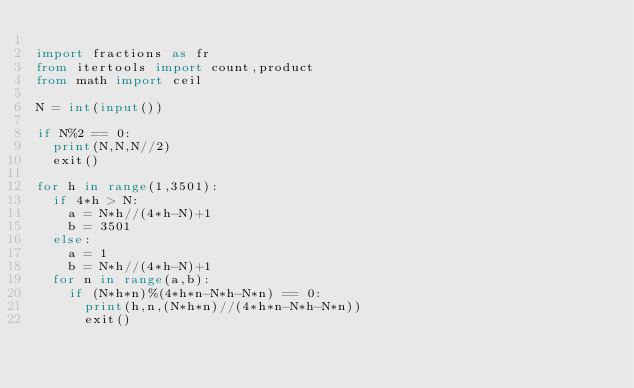<code> <loc_0><loc_0><loc_500><loc_500><_Python_>
import fractions as fr
from itertools import count,product
from math import ceil

N = int(input())

if N%2 == 0:
  print(N,N,N//2)
  exit()

for h in range(1,3501):
  if 4*h > N:
    a = N*h//(4*h-N)+1
    b = 3501
  else:
    a = 1
    b = N*h//(4*h-N)+1
  for n in range(a,b):
    if (N*h*n)%(4*h*n-N*h-N*n) == 0:
      print(h,n,(N*h*n)//(4*h*n-N*h-N*n))
      exit()</code> 